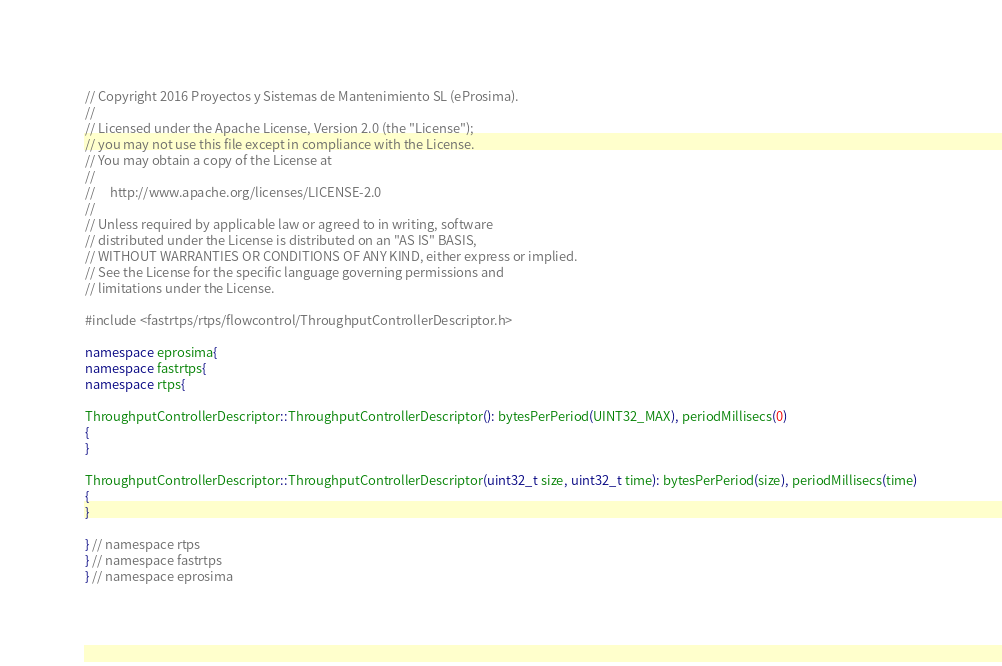Convert code to text. <code><loc_0><loc_0><loc_500><loc_500><_C++_>// Copyright 2016 Proyectos y Sistemas de Mantenimiento SL (eProsima).
//
// Licensed under the Apache License, Version 2.0 (the "License");
// you may not use this file except in compliance with the License.
// You may obtain a copy of the License at
//
//     http://www.apache.org/licenses/LICENSE-2.0
//
// Unless required by applicable law or agreed to in writing, software
// distributed under the License is distributed on an "AS IS" BASIS,
// WITHOUT WARRANTIES OR CONDITIONS OF ANY KIND, either express or implied.
// See the License for the specific language governing permissions and
// limitations under the License.

#include <fastrtps/rtps/flowcontrol/ThroughputControllerDescriptor.h>

namespace eprosima{
namespace fastrtps{
namespace rtps{

ThroughputControllerDescriptor::ThroughputControllerDescriptor(): bytesPerPeriod(UINT32_MAX), periodMillisecs(0)
{
}

ThroughputControllerDescriptor::ThroughputControllerDescriptor(uint32_t size, uint32_t time): bytesPerPeriod(size), periodMillisecs(time)
{
}

} // namespace rtps
} // namespace fastrtps
} // namespace eprosima
</code> 